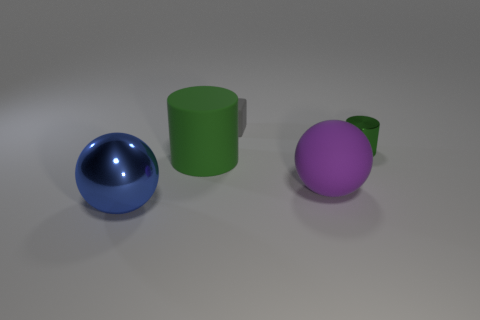Add 5 blue shiny balls. How many objects exist? 10 Subtract all cubes. How many objects are left? 4 Subtract 1 balls. How many balls are left? 1 Add 5 purple matte things. How many purple matte things are left? 6 Add 1 small shiny cylinders. How many small shiny cylinders exist? 2 Subtract 1 gray blocks. How many objects are left? 4 Subtract all purple blocks. Subtract all red balls. How many blocks are left? 1 Subtract all purple cubes. How many blue balls are left? 1 Subtract all gray cubes. Subtract all small brown rubber cylinders. How many objects are left? 4 